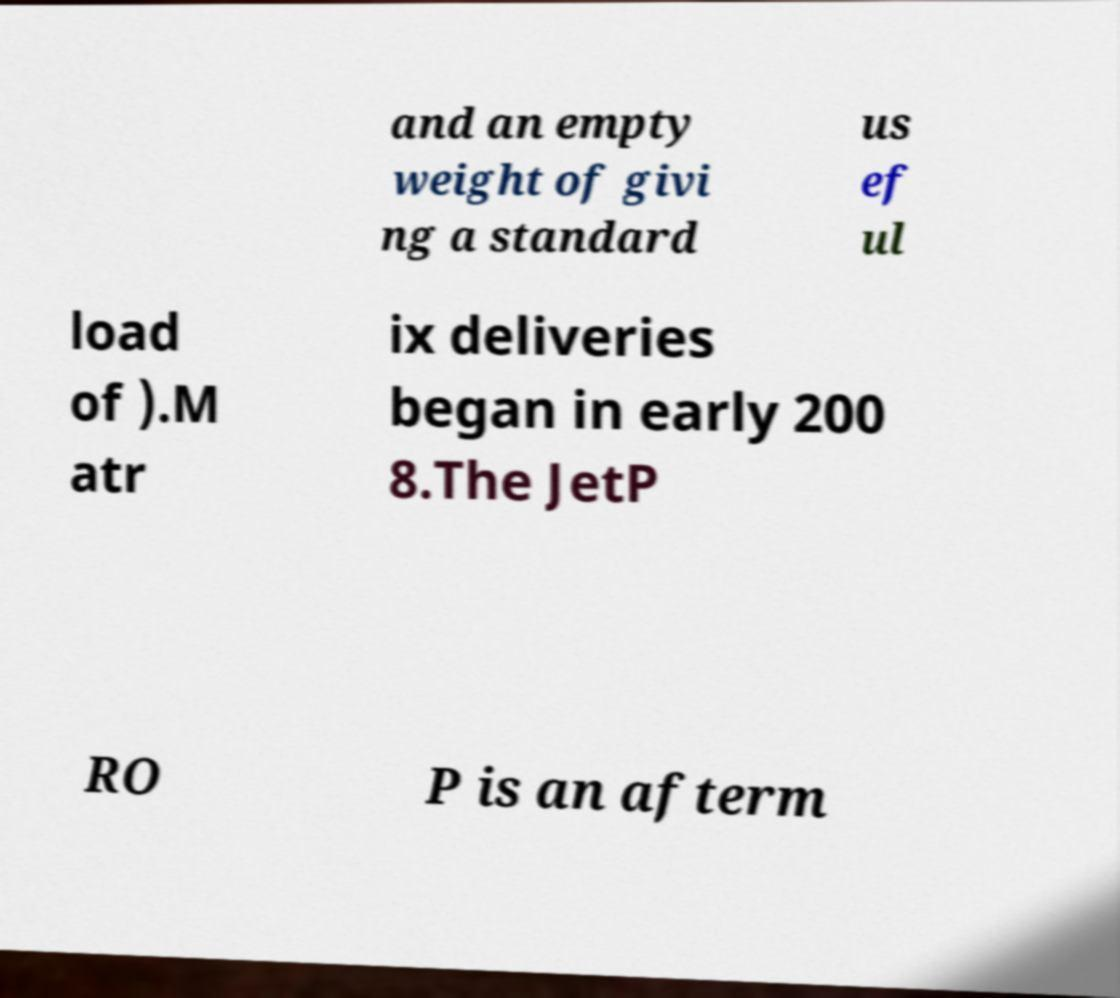Could you extract and type out the text from this image? and an empty weight of givi ng a standard us ef ul load of ).M atr ix deliveries began in early 200 8.The JetP RO P is an afterm 